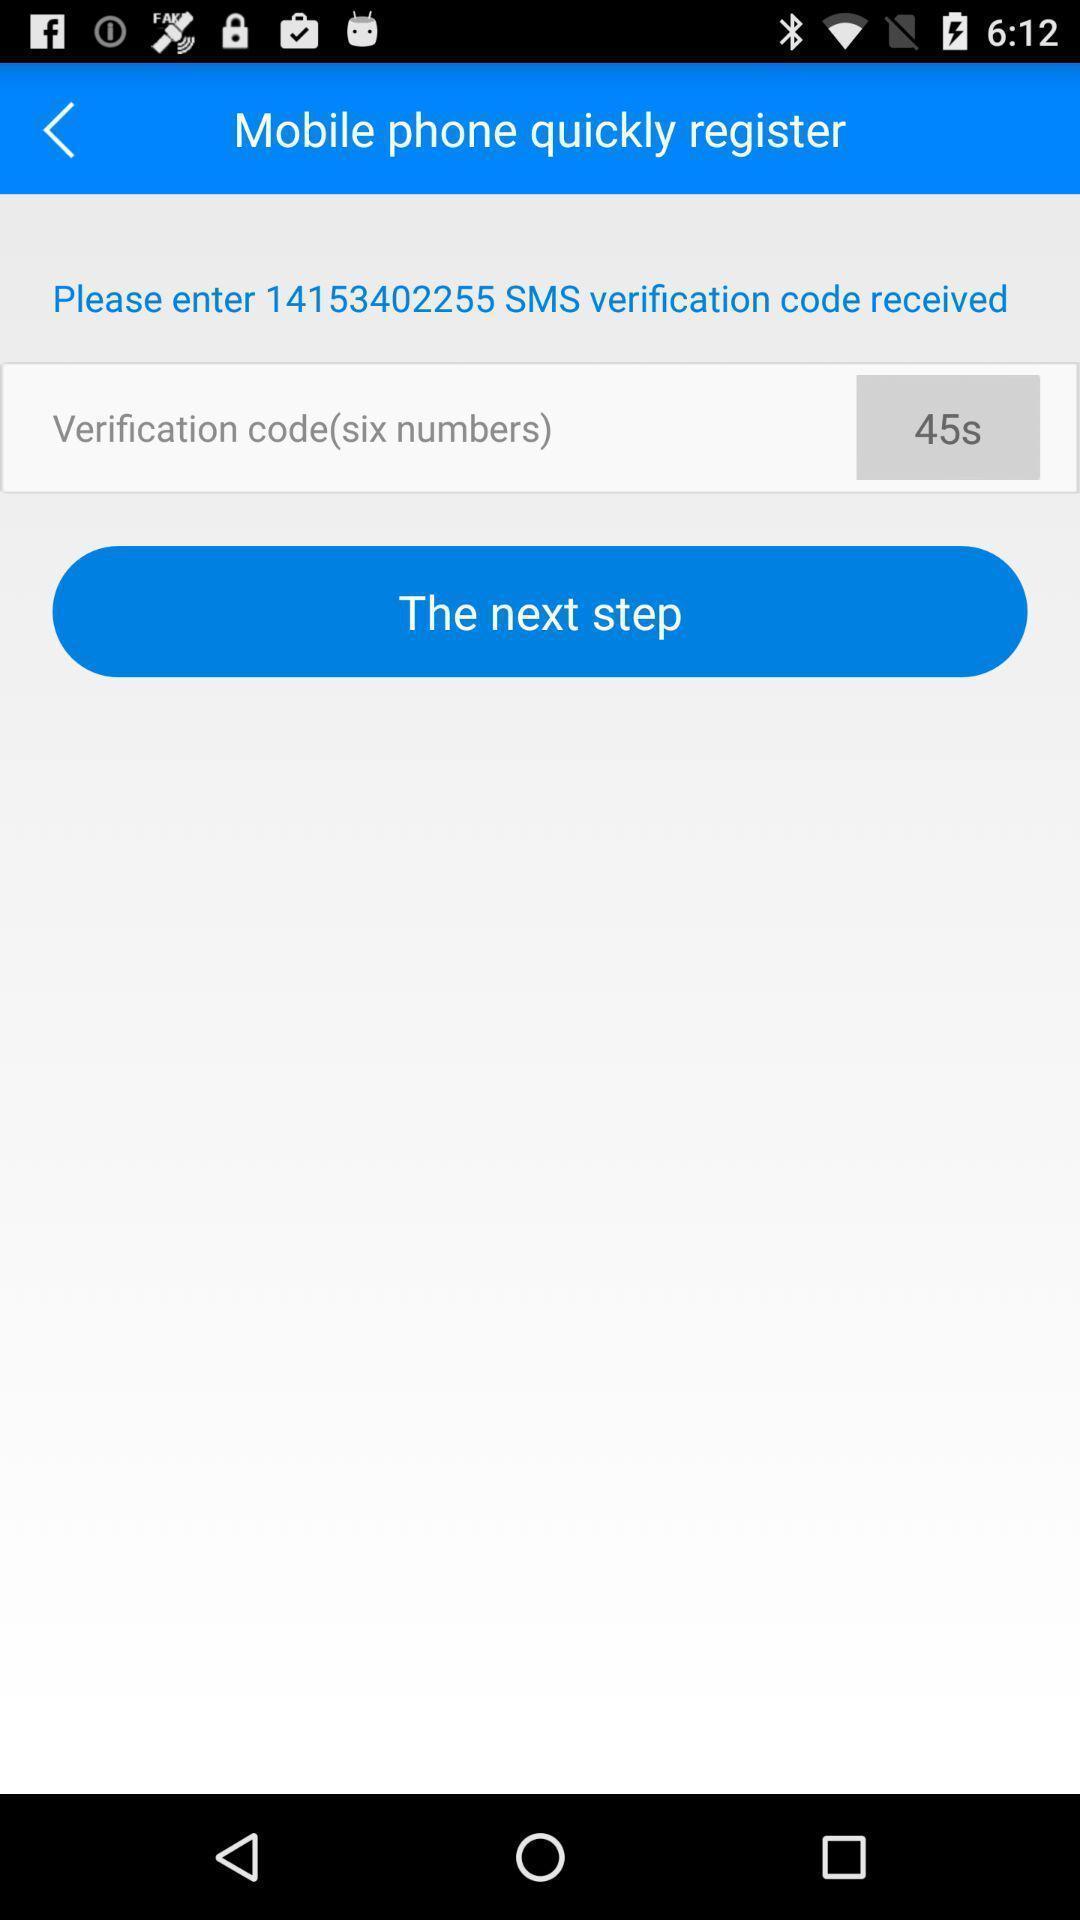Provide a detailed account of this screenshot. Page showing to enter a verification code. 